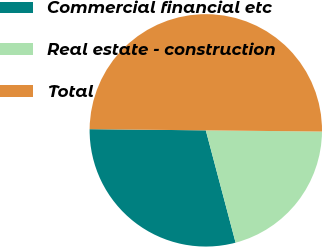<chart> <loc_0><loc_0><loc_500><loc_500><pie_chart><fcel>Commercial financial etc<fcel>Real estate - construction<fcel>Total<nl><fcel>29.29%<fcel>20.71%<fcel>50.0%<nl></chart> 